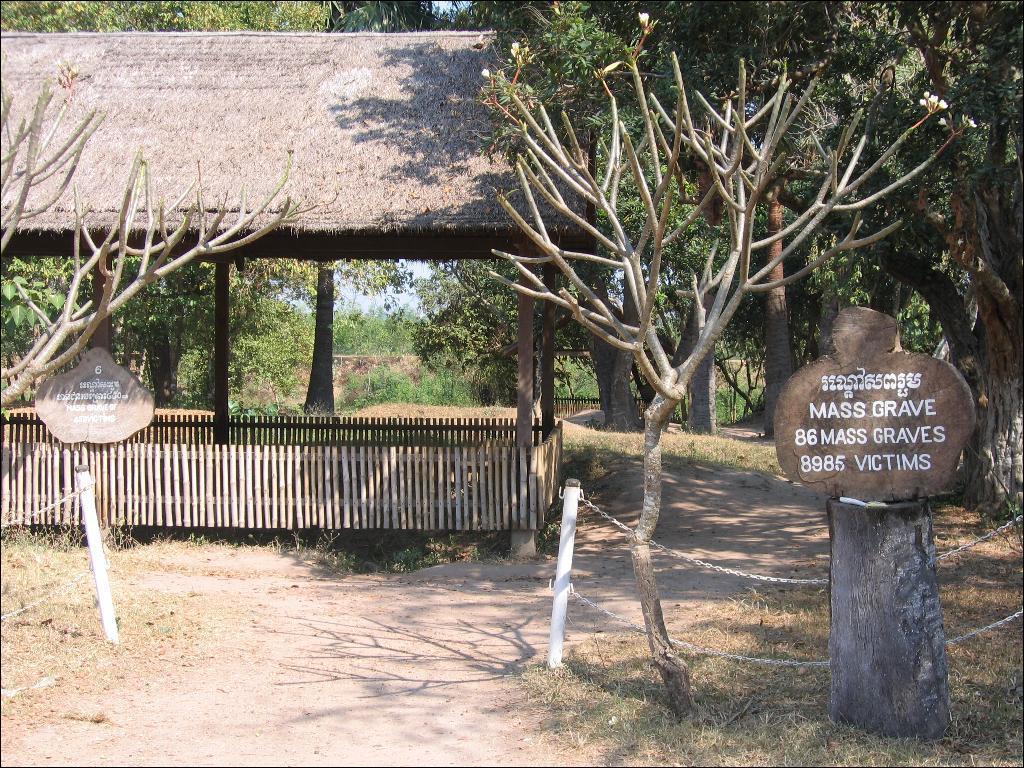Could you give a brief overview of what you see in this image? In this image on the left side there is a shelter, and wooden fence and some boards. On the right side there is a board and a truncated tree, and there are some rods and chains. At the bottom there is walkway and grass, and in the background there are trees. 